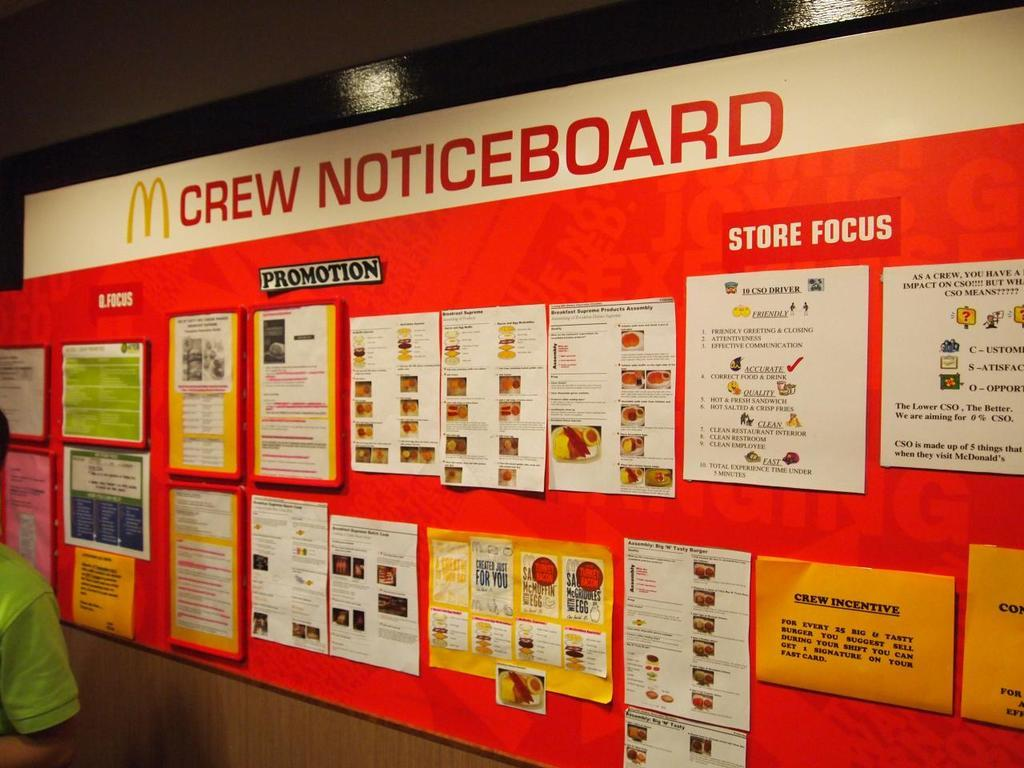<image>
Share a concise interpretation of the image provided. A large wall has paperwork on it and says Crew Noticeboard. 